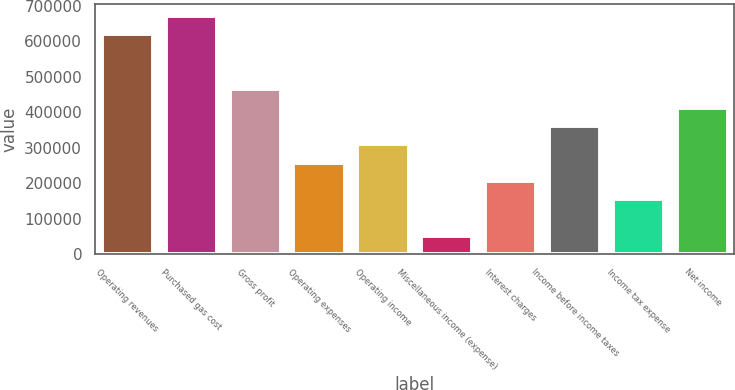Convert chart to OTSL. <chart><loc_0><loc_0><loc_500><loc_500><bar_chart><fcel>Operating revenues<fcel>Purchased gas cost<fcel>Gross profit<fcel>Operating expenses<fcel>Operating income<fcel>Miscellaneous income (expense)<fcel>Interest charges<fcel>Income before income taxes<fcel>Income tax expense<fcel>Net income<nl><fcel>619045<fcel>670632<fcel>464284<fcel>257936<fcel>309523<fcel>51588<fcel>206349<fcel>361110<fcel>154762<fcel>412697<nl></chart> 